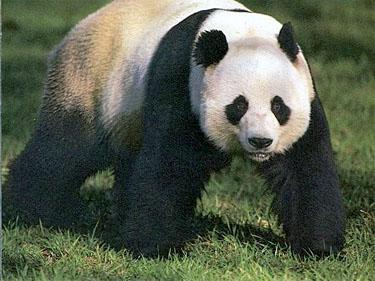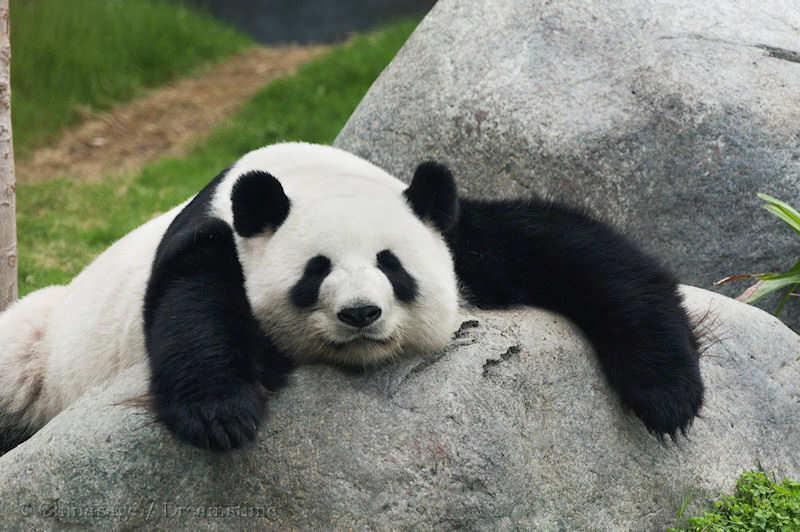The first image is the image on the left, the second image is the image on the right. Considering the images on both sides, is "At least one panda is standing on all 4 legs." valid? Answer yes or no. Yes. 